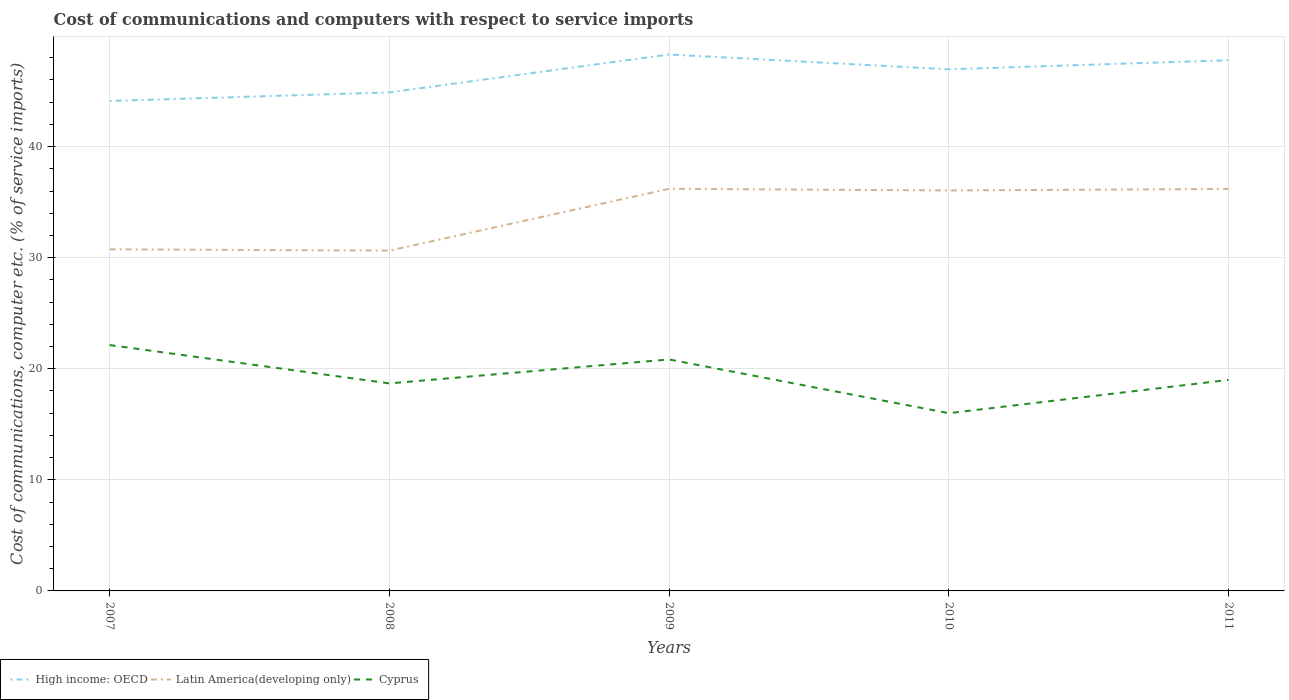Does the line corresponding to Latin America(developing only) intersect with the line corresponding to Cyprus?
Offer a very short reply. No. Is the number of lines equal to the number of legend labels?
Offer a terse response. Yes. Across all years, what is the maximum cost of communications and computers in Latin America(developing only)?
Give a very brief answer. 30.64. What is the total cost of communications and computers in High income: OECD in the graph?
Provide a short and direct response. 0.51. What is the difference between the highest and the second highest cost of communications and computers in Latin America(developing only)?
Keep it short and to the point. 5.57. Is the cost of communications and computers in Latin America(developing only) strictly greater than the cost of communications and computers in Cyprus over the years?
Offer a terse response. No. Does the graph contain grids?
Provide a short and direct response. Yes. How many legend labels are there?
Provide a succinct answer. 3. What is the title of the graph?
Your answer should be compact. Cost of communications and computers with respect to service imports. Does "Namibia" appear as one of the legend labels in the graph?
Your answer should be very brief. No. What is the label or title of the X-axis?
Ensure brevity in your answer.  Years. What is the label or title of the Y-axis?
Make the answer very short. Cost of communications, computer etc. (% of service imports). What is the Cost of communications, computer etc. (% of service imports) in High income: OECD in 2007?
Provide a succinct answer. 44.11. What is the Cost of communications, computer etc. (% of service imports) of Latin America(developing only) in 2007?
Provide a short and direct response. 30.76. What is the Cost of communications, computer etc. (% of service imports) in Cyprus in 2007?
Provide a short and direct response. 22.14. What is the Cost of communications, computer etc. (% of service imports) of High income: OECD in 2008?
Give a very brief answer. 44.88. What is the Cost of communications, computer etc. (% of service imports) of Latin America(developing only) in 2008?
Offer a terse response. 30.64. What is the Cost of communications, computer etc. (% of service imports) in Cyprus in 2008?
Keep it short and to the point. 18.68. What is the Cost of communications, computer etc. (% of service imports) in High income: OECD in 2009?
Ensure brevity in your answer.  48.29. What is the Cost of communications, computer etc. (% of service imports) of Latin America(developing only) in 2009?
Offer a terse response. 36.2. What is the Cost of communications, computer etc. (% of service imports) of Cyprus in 2009?
Offer a terse response. 20.84. What is the Cost of communications, computer etc. (% of service imports) of High income: OECD in 2010?
Provide a short and direct response. 46.96. What is the Cost of communications, computer etc. (% of service imports) of Latin America(developing only) in 2010?
Provide a short and direct response. 36.06. What is the Cost of communications, computer etc. (% of service imports) in Cyprus in 2010?
Provide a short and direct response. 16. What is the Cost of communications, computer etc. (% of service imports) of High income: OECD in 2011?
Your answer should be compact. 47.78. What is the Cost of communications, computer etc. (% of service imports) in Latin America(developing only) in 2011?
Provide a succinct answer. 36.19. What is the Cost of communications, computer etc. (% of service imports) of Cyprus in 2011?
Keep it short and to the point. 19. Across all years, what is the maximum Cost of communications, computer etc. (% of service imports) in High income: OECD?
Provide a short and direct response. 48.29. Across all years, what is the maximum Cost of communications, computer etc. (% of service imports) of Latin America(developing only)?
Your response must be concise. 36.2. Across all years, what is the maximum Cost of communications, computer etc. (% of service imports) in Cyprus?
Offer a terse response. 22.14. Across all years, what is the minimum Cost of communications, computer etc. (% of service imports) in High income: OECD?
Give a very brief answer. 44.11. Across all years, what is the minimum Cost of communications, computer etc. (% of service imports) of Latin America(developing only)?
Give a very brief answer. 30.64. Across all years, what is the minimum Cost of communications, computer etc. (% of service imports) of Cyprus?
Offer a very short reply. 16. What is the total Cost of communications, computer etc. (% of service imports) in High income: OECD in the graph?
Your response must be concise. 232.03. What is the total Cost of communications, computer etc. (% of service imports) in Latin America(developing only) in the graph?
Your answer should be very brief. 169.84. What is the total Cost of communications, computer etc. (% of service imports) of Cyprus in the graph?
Your response must be concise. 96.66. What is the difference between the Cost of communications, computer etc. (% of service imports) of High income: OECD in 2007 and that in 2008?
Your answer should be very brief. -0.77. What is the difference between the Cost of communications, computer etc. (% of service imports) of Latin America(developing only) in 2007 and that in 2008?
Offer a terse response. 0.12. What is the difference between the Cost of communications, computer etc. (% of service imports) of Cyprus in 2007 and that in 2008?
Provide a short and direct response. 3.45. What is the difference between the Cost of communications, computer etc. (% of service imports) in High income: OECD in 2007 and that in 2009?
Your answer should be very brief. -4.18. What is the difference between the Cost of communications, computer etc. (% of service imports) of Latin America(developing only) in 2007 and that in 2009?
Provide a short and direct response. -5.45. What is the difference between the Cost of communications, computer etc. (% of service imports) in Cyprus in 2007 and that in 2009?
Provide a succinct answer. 1.3. What is the difference between the Cost of communications, computer etc. (% of service imports) of High income: OECD in 2007 and that in 2010?
Your answer should be compact. -2.85. What is the difference between the Cost of communications, computer etc. (% of service imports) of Latin America(developing only) in 2007 and that in 2010?
Provide a succinct answer. -5.3. What is the difference between the Cost of communications, computer etc. (% of service imports) in Cyprus in 2007 and that in 2010?
Keep it short and to the point. 6.14. What is the difference between the Cost of communications, computer etc. (% of service imports) in High income: OECD in 2007 and that in 2011?
Make the answer very short. -3.67. What is the difference between the Cost of communications, computer etc. (% of service imports) of Latin America(developing only) in 2007 and that in 2011?
Your answer should be very brief. -5.43. What is the difference between the Cost of communications, computer etc. (% of service imports) in Cyprus in 2007 and that in 2011?
Provide a short and direct response. 3.14. What is the difference between the Cost of communications, computer etc. (% of service imports) of High income: OECD in 2008 and that in 2009?
Make the answer very short. -3.41. What is the difference between the Cost of communications, computer etc. (% of service imports) of Latin America(developing only) in 2008 and that in 2009?
Ensure brevity in your answer.  -5.57. What is the difference between the Cost of communications, computer etc. (% of service imports) of Cyprus in 2008 and that in 2009?
Keep it short and to the point. -2.16. What is the difference between the Cost of communications, computer etc. (% of service imports) of High income: OECD in 2008 and that in 2010?
Offer a terse response. -2.08. What is the difference between the Cost of communications, computer etc. (% of service imports) of Latin America(developing only) in 2008 and that in 2010?
Keep it short and to the point. -5.42. What is the difference between the Cost of communications, computer etc. (% of service imports) of Cyprus in 2008 and that in 2010?
Ensure brevity in your answer.  2.68. What is the difference between the Cost of communications, computer etc. (% of service imports) in High income: OECD in 2008 and that in 2011?
Provide a short and direct response. -2.9. What is the difference between the Cost of communications, computer etc. (% of service imports) in Latin America(developing only) in 2008 and that in 2011?
Offer a very short reply. -5.55. What is the difference between the Cost of communications, computer etc. (% of service imports) in Cyprus in 2008 and that in 2011?
Give a very brief answer. -0.31. What is the difference between the Cost of communications, computer etc. (% of service imports) in High income: OECD in 2009 and that in 2010?
Your answer should be compact. 1.33. What is the difference between the Cost of communications, computer etc. (% of service imports) in Latin America(developing only) in 2009 and that in 2010?
Ensure brevity in your answer.  0.15. What is the difference between the Cost of communications, computer etc. (% of service imports) in Cyprus in 2009 and that in 2010?
Offer a very short reply. 4.84. What is the difference between the Cost of communications, computer etc. (% of service imports) of High income: OECD in 2009 and that in 2011?
Make the answer very short. 0.51. What is the difference between the Cost of communications, computer etc. (% of service imports) of Latin America(developing only) in 2009 and that in 2011?
Ensure brevity in your answer.  0.01. What is the difference between the Cost of communications, computer etc. (% of service imports) of Cyprus in 2009 and that in 2011?
Your answer should be very brief. 1.84. What is the difference between the Cost of communications, computer etc. (% of service imports) of High income: OECD in 2010 and that in 2011?
Your answer should be very brief. -0.82. What is the difference between the Cost of communications, computer etc. (% of service imports) of Latin America(developing only) in 2010 and that in 2011?
Your answer should be very brief. -0.13. What is the difference between the Cost of communications, computer etc. (% of service imports) in Cyprus in 2010 and that in 2011?
Provide a succinct answer. -3. What is the difference between the Cost of communications, computer etc. (% of service imports) of High income: OECD in 2007 and the Cost of communications, computer etc. (% of service imports) of Latin America(developing only) in 2008?
Provide a succinct answer. 13.47. What is the difference between the Cost of communications, computer etc. (% of service imports) of High income: OECD in 2007 and the Cost of communications, computer etc. (% of service imports) of Cyprus in 2008?
Provide a short and direct response. 25.43. What is the difference between the Cost of communications, computer etc. (% of service imports) in Latin America(developing only) in 2007 and the Cost of communications, computer etc. (% of service imports) in Cyprus in 2008?
Your answer should be very brief. 12.07. What is the difference between the Cost of communications, computer etc. (% of service imports) of High income: OECD in 2007 and the Cost of communications, computer etc. (% of service imports) of Latin America(developing only) in 2009?
Your response must be concise. 7.91. What is the difference between the Cost of communications, computer etc. (% of service imports) of High income: OECD in 2007 and the Cost of communications, computer etc. (% of service imports) of Cyprus in 2009?
Give a very brief answer. 23.27. What is the difference between the Cost of communications, computer etc. (% of service imports) in Latin America(developing only) in 2007 and the Cost of communications, computer etc. (% of service imports) in Cyprus in 2009?
Offer a terse response. 9.92. What is the difference between the Cost of communications, computer etc. (% of service imports) of High income: OECD in 2007 and the Cost of communications, computer etc. (% of service imports) of Latin America(developing only) in 2010?
Your answer should be compact. 8.06. What is the difference between the Cost of communications, computer etc. (% of service imports) of High income: OECD in 2007 and the Cost of communications, computer etc. (% of service imports) of Cyprus in 2010?
Offer a very short reply. 28.11. What is the difference between the Cost of communications, computer etc. (% of service imports) in Latin America(developing only) in 2007 and the Cost of communications, computer etc. (% of service imports) in Cyprus in 2010?
Keep it short and to the point. 14.76. What is the difference between the Cost of communications, computer etc. (% of service imports) in High income: OECD in 2007 and the Cost of communications, computer etc. (% of service imports) in Latin America(developing only) in 2011?
Give a very brief answer. 7.92. What is the difference between the Cost of communications, computer etc. (% of service imports) of High income: OECD in 2007 and the Cost of communications, computer etc. (% of service imports) of Cyprus in 2011?
Provide a succinct answer. 25.11. What is the difference between the Cost of communications, computer etc. (% of service imports) of Latin America(developing only) in 2007 and the Cost of communications, computer etc. (% of service imports) of Cyprus in 2011?
Provide a succinct answer. 11.76. What is the difference between the Cost of communications, computer etc. (% of service imports) in High income: OECD in 2008 and the Cost of communications, computer etc. (% of service imports) in Latin America(developing only) in 2009?
Offer a very short reply. 8.68. What is the difference between the Cost of communications, computer etc. (% of service imports) in High income: OECD in 2008 and the Cost of communications, computer etc. (% of service imports) in Cyprus in 2009?
Your answer should be compact. 24.04. What is the difference between the Cost of communications, computer etc. (% of service imports) of Latin America(developing only) in 2008 and the Cost of communications, computer etc. (% of service imports) of Cyprus in 2009?
Provide a short and direct response. 9.8. What is the difference between the Cost of communications, computer etc. (% of service imports) in High income: OECD in 2008 and the Cost of communications, computer etc. (% of service imports) in Latin America(developing only) in 2010?
Your response must be concise. 8.83. What is the difference between the Cost of communications, computer etc. (% of service imports) in High income: OECD in 2008 and the Cost of communications, computer etc. (% of service imports) in Cyprus in 2010?
Ensure brevity in your answer.  28.88. What is the difference between the Cost of communications, computer etc. (% of service imports) of Latin America(developing only) in 2008 and the Cost of communications, computer etc. (% of service imports) of Cyprus in 2010?
Offer a very short reply. 14.64. What is the difference between the Cost of communications, computer etc. (% of service imports) of High income: OECD in 2008 and the Cost of communications, computer etc. (% of service imports) of Latin America(developing only) in 2011?
Your answer should be compact. 8.69. What is the difference between the Cost of communications, computer etc. (% of service imports) in High income: OECD in 2008 and the Cost of communications, computer etc. (% of service imports) in Cyprus in 2011?
Give a very brief answer. 25.89. What is the difference between the Cost of communications, computer etc. (% of service imports) of Latin America(developing only) in 2008 and the Cost of communications, computer etc. (% of service imports) of Cyprus in 2011?
Offer a terse response. 11.64. What is the difference between the Cost of communications, computer etc. (% of service imports) in High income: OECD in 2009 and the Cost of communications, computer etc. (% of service imports) in Latin America(developing only) in 2010?
Make the answer very short. 12.24. What is the difference between the Cost of communications, computer etc. (% of service imports) in High income: OECD in 2009 and the Cost of communications, computer etc. (% of service imports) in Cyprus in 2010?
Provide a succinct answer. 32.29. What is the difference between the Cost of communications, computer etc. (% of service imports) in Latin America(developing only) in 2009 and the Cost of communications, computer etc. (% of service imports) in Cyprus in 2010?
Give a very brief answer. 20.2. What is the difference between the Cost of communications, computer etc. (% of service imports) in High income: OECD in 2009 and the Cost of communications, computer etc. (% of service imports) in Latin America(developing only) in 2011?
Your answer should be very brief. 12.1. What is the difference between the Cost of communications, computer etc. (% of service imports) in High income: OECD in 2009 and the Cost of communications, computer etc. (% of service imports) in Cyprus in 2011?
Keep it short and to the point. 29.3. What is the difference between the Cost of communications, computer etc. (% of service imports) of Latin America(developing only) in 2009 and the Cost of communications, computer etc. (% of service imports) of Cyprus in 2011?
Make the answer very short. 17.21. What is the difference between the Cost of communications, computer etc. (% of service imports) of High income: OECD in 2010 and the Cost of communications, computer etc. (% of service imports) of Latin America(developing only) in 2011?
Provide a succinct answer. 10.77. What is the difference between the Cost of communications, computer etc. (% of service imports) in High income: OECD in 2010 and the Cost of communications, computer etc. (% of service imports) in Cyprus in 2011?
Ensure brevity in your answer.  27.96. What is the difference between the Cost of communications, computer etc. (% of service imports) of Latin America(developing only) in 2010 and the Cost of communications, computer etc. (% of service imports) of Cyprus in 2011?
Your answer should be compact. 17.06. What is the average Cost of communications, computer etc. (% of service imports) in High income: OECD per year?
Offer a very short reply. 46.41. What is the average Cost of communications, computer etc. (% of service imports) of Latin America(developing only) per year?
Offer a terse response. 33.97. What is the average Cost of communications, computer etc. (% of service imports) of Cyprus per year?
Ensure brevity in your answer.  19.33. In the year 2007, what is the difference between the Cost of communications, computer etc. (% of service imports) of High income: OECD and Cost of communications, computer etc. (% of service imports) of Latin America(developing only)?
Ensure brevity in your answer.  13.35. In the year 2007, what is the difference between the Cost of communications, computer etc. (% of service imports) of High income: OECD and Cost of communications, computer etc. (% of service imports) of Cyprus?
Keep it short and to the point. 21.98. In the year 2007, what is the difference between the Cost of communications, computer etc. (% of service imports) of Latin America(developing only) and Cost of communications, computer etc. (% of service imports) of Cyprus?
Provide a succinct answer. 8.62. In the year 2008, what is the difference between the Cost of communications, computer etc. (% of service imports) in High income: OECD and Cost of communications, computer etc. (% of service imports) in Latin America(developing only)?
Give a very brief answer. 14.25. In the year 2008, what is the difference between the Cost of communications, computer etc. (% of service imports) in High income: OECD and Cost of communications, computer etc. (% of service imports) in Cyprus?
Ensure brevity in your answer.  26.2. In the year 2008, what is the difference between the Cost of communications, computer etc. (% of service imports) in Latin America(developing only) and Cost of communications, computer etc. (% of service imports) in Cyprus?
Provide a short and direct response. 11.95. In the year 2009, what is the difference between the Cost of communications, computer etc. (% of service imports) of High income: OECD and Cost of communications, computer etc. (% of service imports) of Latin America(developing only)?
Your answer should be very brief. 12.09. In the year 2009, what is the difference between the Cost of communications, computer etc. (% of service imports) in High income: OECD and Cost of communications, computer etc. (% of service imports) in Cyprus?
Give a very brief answer. 27.46. In the year 2009, what is the difference between the Cost of communications, computer etc. (% of service imports) of Latin America(developing only) and Cost of communications, computer etc. (% of service imports) of Cyprus?
Your answer should be compact. 15.36. In the year 2010, what is the difference between the Cost of communications, computer etc. (% of service imports) in High income: OECD and Cost of communications, computer etc. (% of service imports) in Latin America(developing only)?
Ensure brevity in your answer.  10.91. In the year 2010, what is the difference between the Cost of communications, computer etc. (% of service imports) in High income: OECD and Cost of communications, computer etc. (% of service imports) in Cyprus?
Keep it short and to the point. 30.96. In the year 2010, what is the difference between the Cost of communications, computer etc. (% of service imports) in Latin America(developing only) and Cost of communications, computer etc. (% of service imports) in Cyprus?
Give a very brief answer. 20.06. In the year 2011, what is the difference between the Cost of communications, computer etc. (% of service imports) of High income: OECD and Cost of communications, computer etc. (% of service imports) of Latin America(developing only)?
Provide a short and direct response. 11.59. In the year 2011, what is the difference between the Cost of communications, computer etc. (% of service imports) in High income: OECD and Cost of communications, computer etc. (% of service imports) in Cyprus?
Your answer should be compact. 28.78. In the year 2011, what is the difference between the Cost of communications, computer etc. (% of service imports) in Latin America(developing only) and Cost of communications, computer etc. (% of service imports) in Cyprus?
Your answer should be compact. 17.19. What is the ratio of the Cost of communications, computer etc. (% of service imports) of High income: OECD in 2007 to that in 2008?
Provide a short and direct response. 0.98. What is the ratio of the Cost of communications, computer etc. (% of service imports) of Latin America(developing only) in 2007 to that in 2008?
Keep it short and to the point. 1. What is the ratio of the Cost of communications, computer etc. (% of service imports) in Cyprus in 2007 to that in 2008?
Keep it short and to the point. 1.18. What is the ratio of the Cost of communications, computer etc. (% of service imports) in High income: OECD in 2007 to that in 2009?
Provide a short and direct response. 0.91. What is the ratio of the Cost of communications, computer etc. (% of service imports) of Latin America(developing only) in 2007 to that in 2009?
Your response must be concise. 0.85. What is the ratio of the Cost of communications, computer etc. (% of service imports) in Cyprus in 2007 to that in 2009?
Make the answer very short. 1.06. What is the ratio of the Cost of communications, computer etc. (% of service imports) of High income: OECD in 2007 to that in 2010?
Provide a short and direct response. 0.94. What is the ratio of the Cost of communications, computer etc. (% of service imports) of Latin America(developing only) in 2007 to that in 2010?
Ensure brevity in your answer.  0.85. What is the ratio of the Cost of communications, computer etc. (% of service imports) of Cyprus in 2007 to that in 2010?
Your answer should be compact. 1.38. What is the ratio of the Cost of communications, computer etc. (% of service imports) of High income: OECD in 2007 to that in 2011?
Offer a very short reply. 0.92. What is the ratio of the Cost of communications, computer etc. (% of service imports) in Latin America(developing only) in 2007 to that in 2011?
Your answer should be compact. 0.85. What is the ratio of the Cost of communications, computer etc. (% of service imports) of Cyprus in 2007 to that in 2011?
Provide a short and direct response. 1.17. What is the ratio of the Cost of communications, computer etc. (% of service imports) of High income: OECD in 2008 to that in 2009?
Your answer should be very brief. 0.93. What is the ratio of the Cost of communications, computer etc. (% of service imports) of Latin America(developing only) in 2008 to that in 2009?
Ensure brevity in your answer.  0.85. What is the ratio of the Cost of communications, computer etc. (% of service imports) of Cyprus in 2008 to that in 2009?
Your answer should be very brief. 0.9. What is the ratio of the Cost of communications, computer etc. (% of service imports) of High income: OECD in 2008 to that in 2010?
Offer a very short reply. 0.96. What is the ratio of the Cost of communications, computer etc. (% of service imports) in Latin America(developing only) in 2008 to that in 2010?
Make the answer very short. 0.85. What is the ratio of the Cost of communications, computer etc. (% of service imports) in Cyprus in 2008 to that in 2010?
Your response must be concise. 1.17. What is the ratio of the Cost of communications, computer etc. (% of service imports) in High income: OECD in 2008 to that in 2011?
Give a very brief answer. 0.94. What is the ratio of the Cost of communications, computer etc. (% of service imports) of Latin America(developing only) in 2008 to that in 2011?
Provide a succinct answer. 0.85. What is the ratio of the Cost of communications, computer etc. (% of service imports) of Cyprus in 2008 to that in 2011?
Give a very brief answer. 0.98. What is the ratio of the Cost of communications, computer etc. (% of service imports) in High income: OECD in 2009 to that in 2010?
Your answer should be very brief. 1.03. What is the ratio of the Cost of communications, computer etc. (% of service imports) in Latin America(developing only) in 2009 to that in 2010?
Offer a terse response. 1. What is the ratio of the Cost of communications, computer etc. (% of service imports) in Cyprus in 2009 to that in 2010?
Provide a short and direct response. 1.3. What is the ratio of the Cost of communications, computer etc. (% of service imports) in High income: OECD in 2009 to that in 2011?
Your answer should be compact. 1.01. What is the ratio of the Cost of communications, computer etc. (% of service imports) in Cyprus in 2009 to that in 2011?
Your answer should be compact. 1.1. What is the ratio of the Cost of communications, computer etc. (% of service imports) in High income: OECD in 2010 to that in 2011?
Provide a succinct answer. 0.98. What is the ratio of the Cost of communications, computer etc. (% of service imports) in Cyprus in 2010 to that in 2011?
Ensure brevity in your answer.  0.84. What is the difference between the highest and the second highest Cost of communications, computer etc. (% of service imports) of High income: OECD?
Make the answer very short. 0.51. What is the difference between the highest and the second highest Cost of communications, computer etc. (% of service imports) in Latin America(developing only)?
Your answer should be compact. 0.01. What is the difference between the highest and the second highest Cost of communications, computer etc. (% of service imports) in Cyprus?
Provide a succinct answer. 1.3. What is the difference between the highest and the lowest Cost of communications, computer etc. (% of service imports) of High income: OECD?
Your response must be concise. 4.18. What is the difference between the highest and the lowest Cost of communications, computer etc. (% of service imports) in Latin America(developing only)?
Your response must be concise. 5.57. What is the difference between the highest and the lowest Cost of communications, computer etc. (% of service imports) of Cyprus?
Provide a succinct answer. 6.14. 